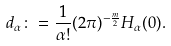Convert formula to latex. <formula><loc_0><loc_0><loc_500><loc_500>d _ { \alpha } \colon = \frac { 1 } { \alpha ! } ( 2 \pi ) ^ { - \frac { m } { 2 } } H _ { \alpha } ( 0 ) .</formula> 